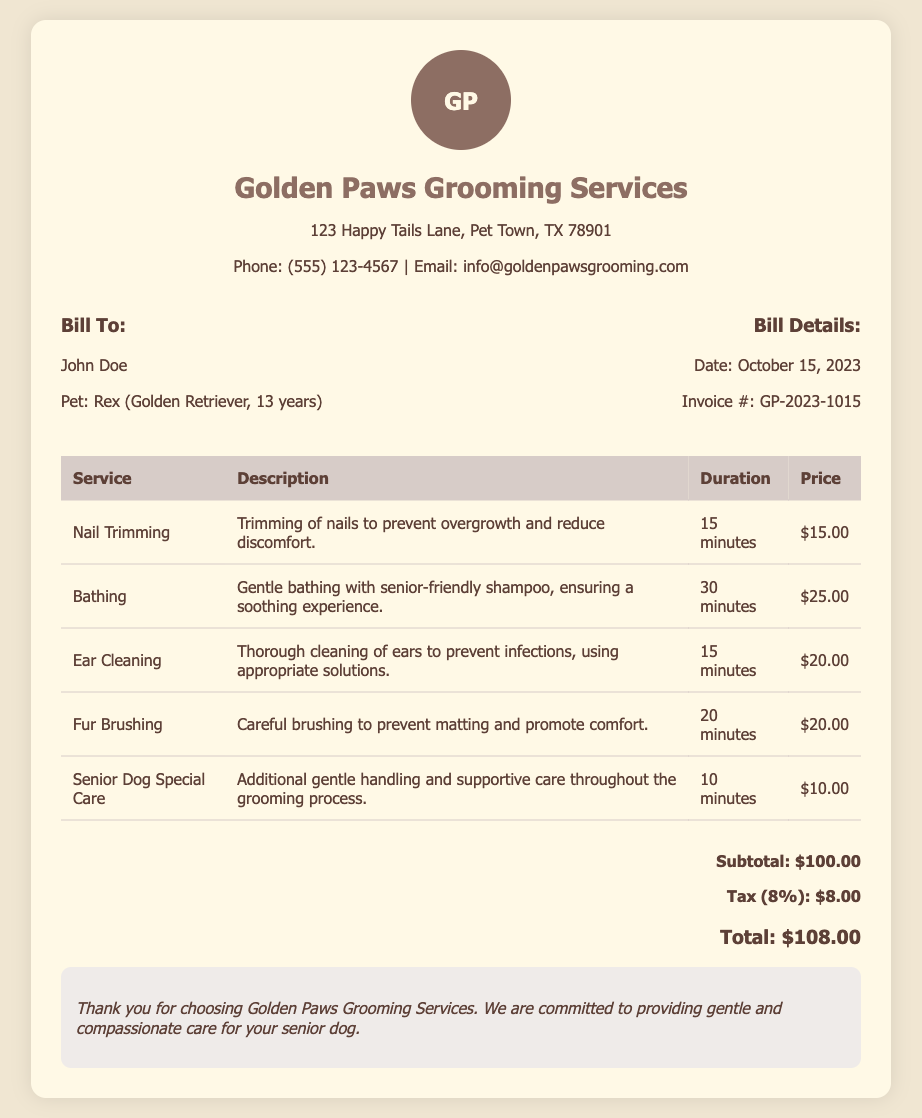What is the invoice number? The invoice number is listed in the bill details section of the document.
Answer: GP-2023-1015 What is the total cost for the grooming services? The total cost is displayed at the bottom of the bill.
Answer: $108.00 What is the price for nail trimming? The price for nail trimming is found in the service breakdown table.
Answer: $15.00 How long did the bathing service take? The duration for bathing is indicated in the service duration column of the table.
Answer: 30 minutes Who is the bill addressed to? The bill is addressed to the person listed in the "Bill To" section.
Answer: John Doe What type of dog is mentioned in the bill? The type of dog is information provided alongside the owner's details.
Answer: Golden Retriever How much was charged for the Senior Dog Special Care? The price for Senior Dog Special Care is listed in the pricing section of the document.
Answer: $10.00 What tax percentage was applied to the total? The tax percentage can be found in the total cost section of the document.
Answer: 8% What kind of shampoo was used for bathing? The description for bathing mentions the type of shampoo used.
Answer: senior-friendly shampoo How many services are listed in the document? The number of services can be derived from counting the rows in the service table.
Answer: 5 